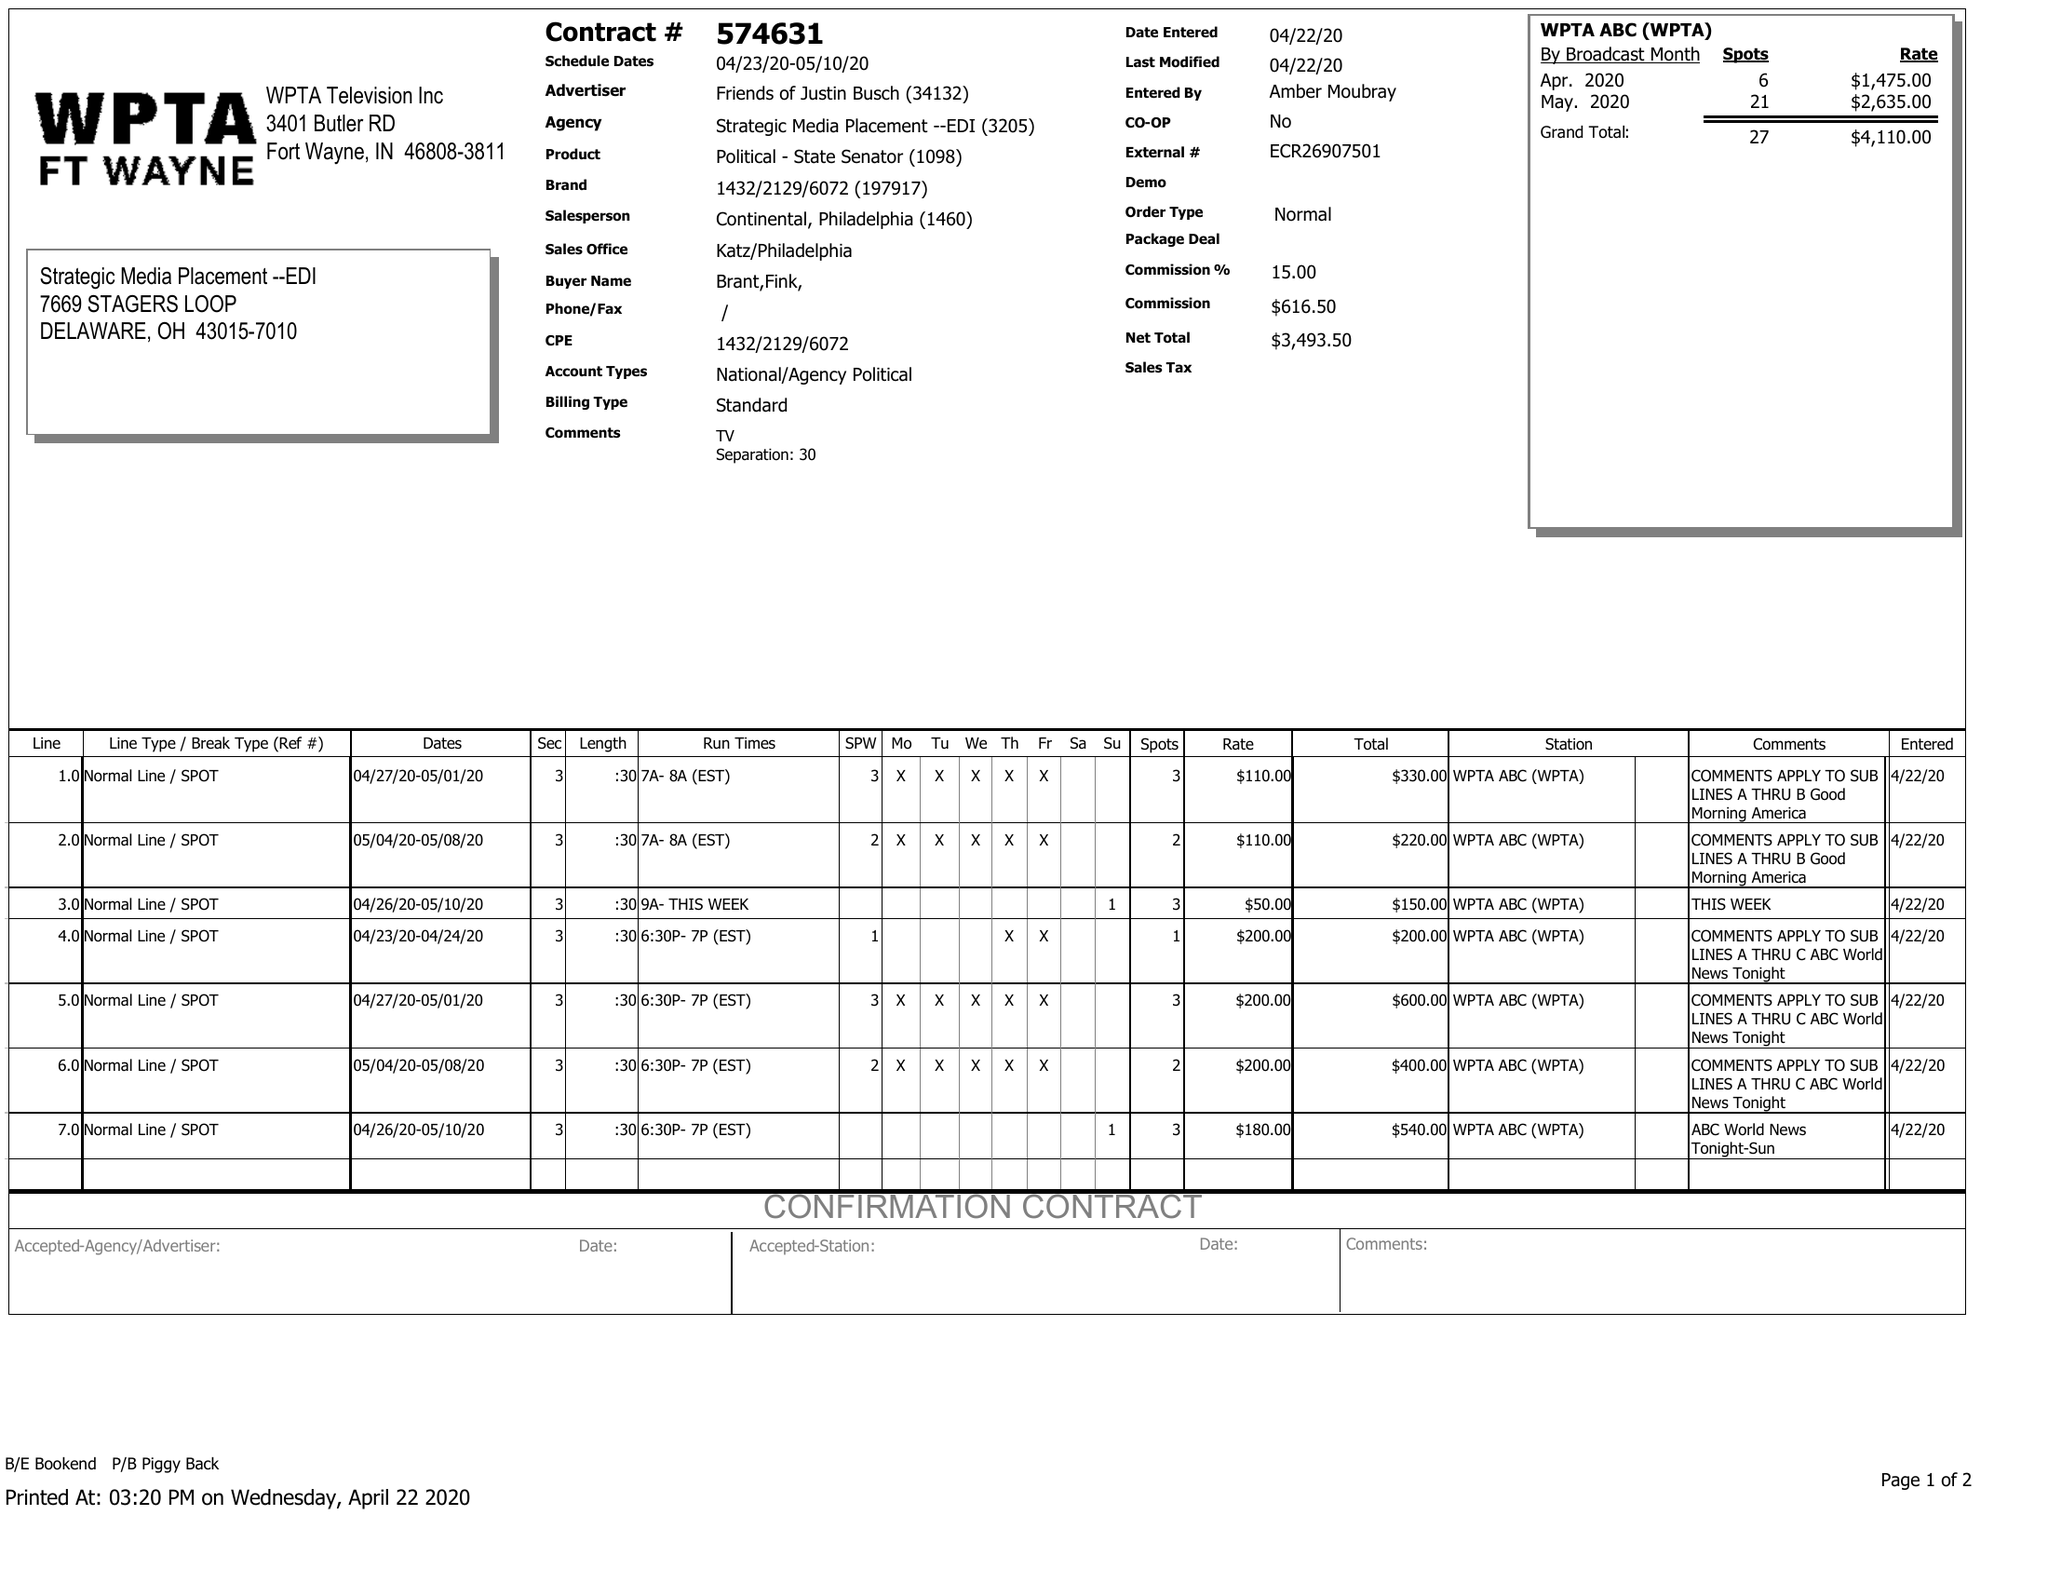What is the value for the advertiser?
Answer the question using a single word or phrase. FRIENDS OF JUSTIN BUSCH 